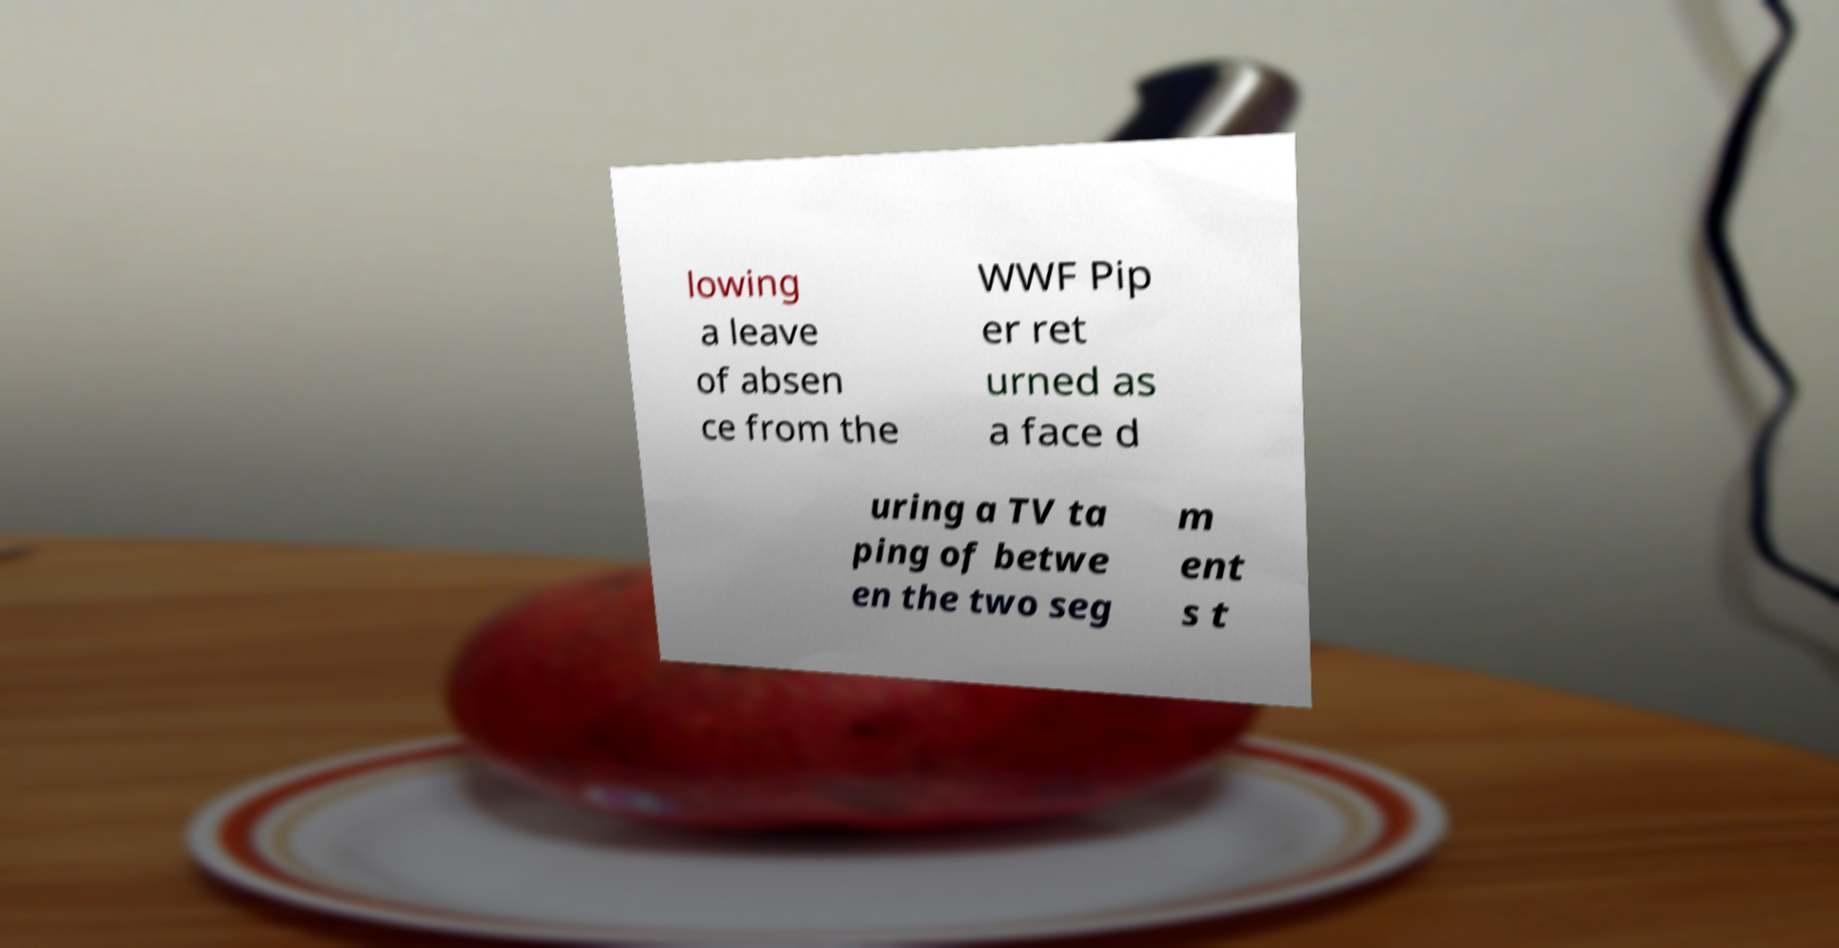There's text embedded in this image that I need extracted. Can you transcribe it verbatim? lowing a leave of absen ce from the WWF Pip er ret urned as a face d uring a TV ta ping of betwe en the two seg m ent s t 